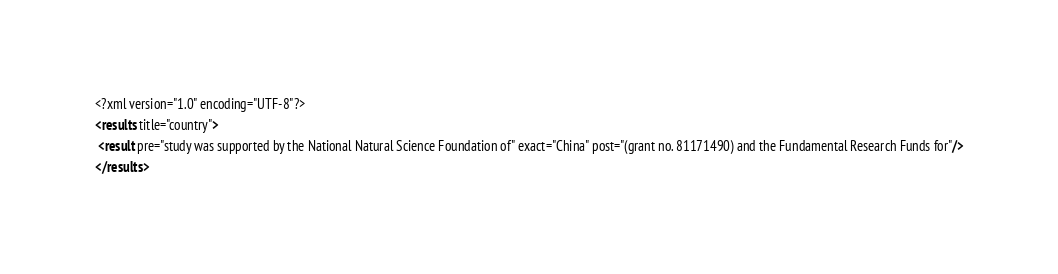<code> <loc_0><loc_0><loc_500><loc_500><_XML_><?xml version="1.0" encoding="UTF-8"?>
<results title="country">
 <result pre="study was supported by the National Natural Science Foundation of" exact="China" post="(grant no. 81171490) and the Fundamental Research Funds for"/>
</results>
</code> 